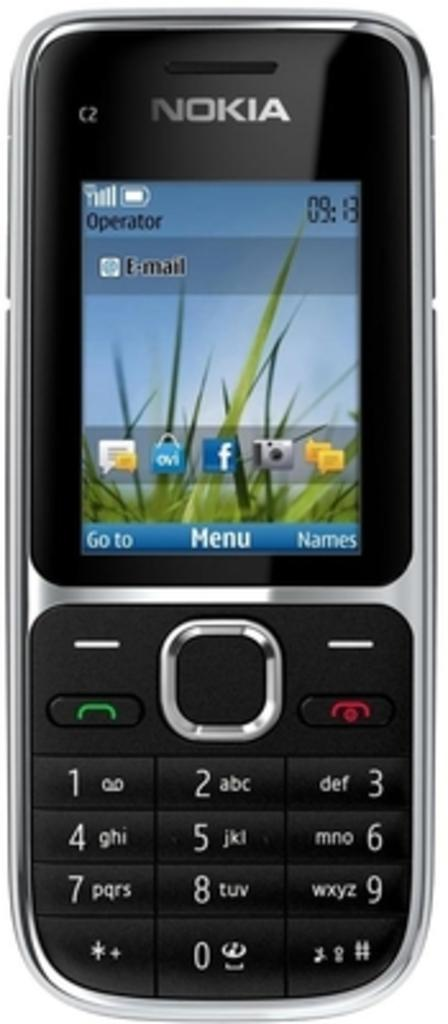<image>
Describe the image concisely. A phone that has the ability to show emails. 